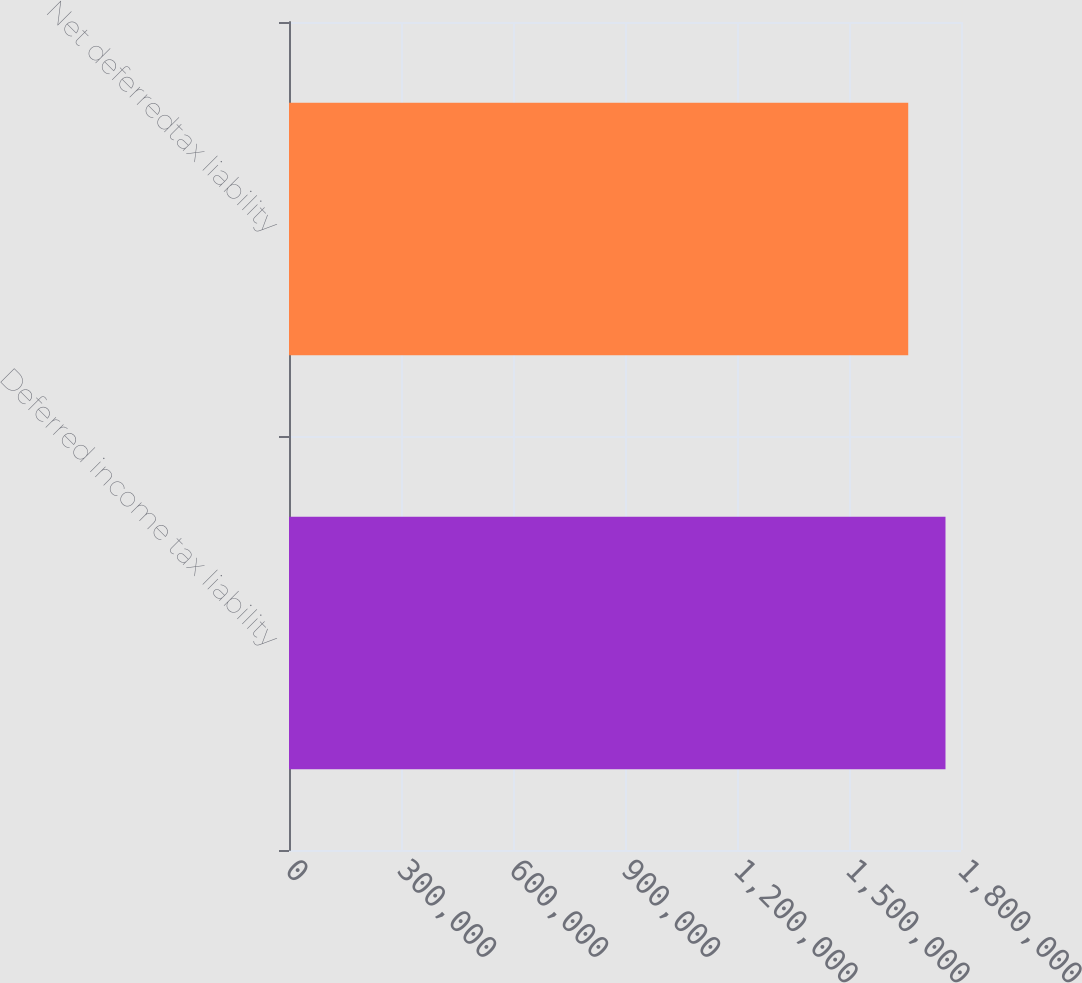Convert chart. <chart><loc_0><loc_0><loc_500><loc_500><bar_chart><fcel>Deferred income tax liability<fcel>Net deferredtax liability<nl><fcel>1.75845e+06<fcel>1.65862e+06<nl></chart> 